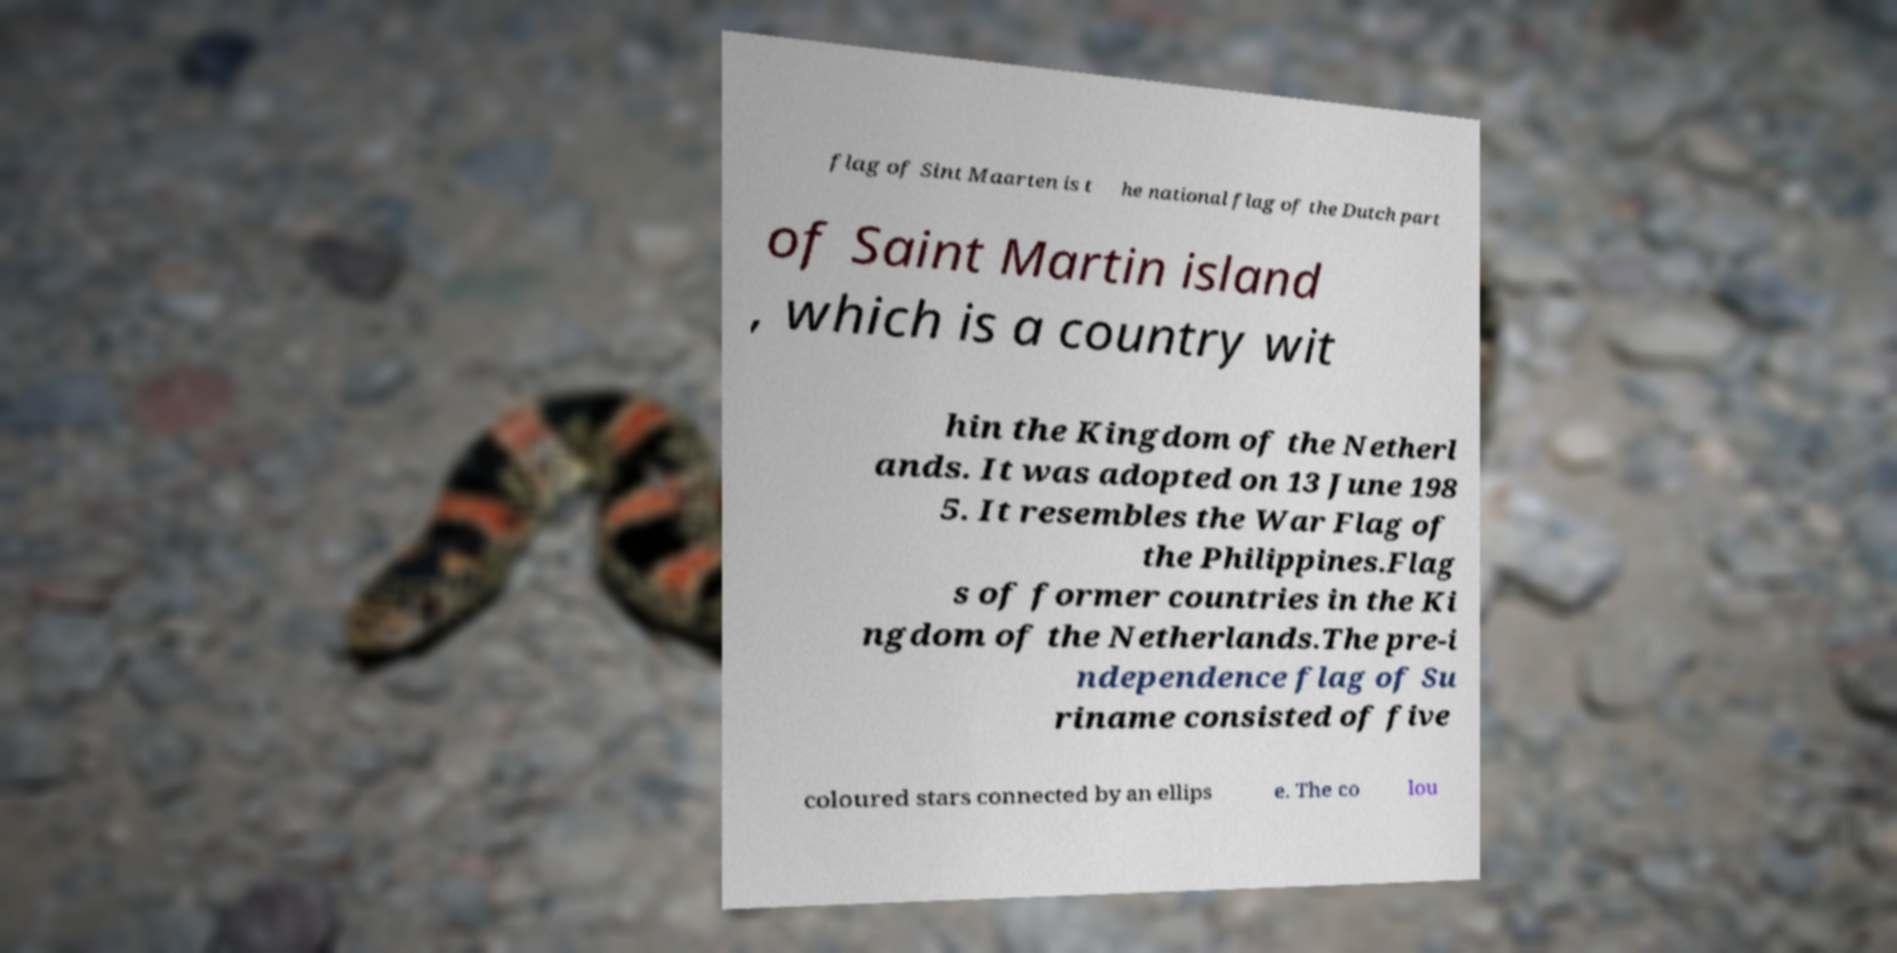For documentation purposes, I need the text within this image transcribed. Could you provide that? flag of Sint Maarten is t he national flag of the Dutch part of Saint Martin island , which is a country wit hin the Kingdom of the Netherl ands. It was adopted on 13 June 198 5. It resembles the War Flag of the Philippines.Flag s of former countries in the Ki ngdom of the Netherlands.The pre-i ndependence flag of Su riname consisted of five coloured stars connected by an ellips e. The co lou 